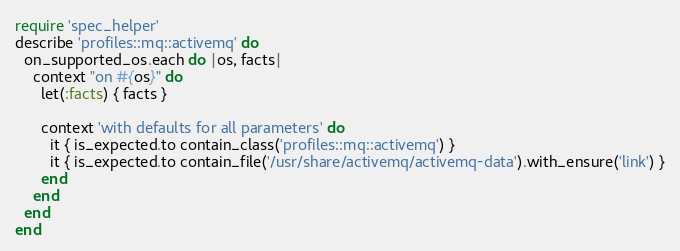<code> <loc_0><loc_0><loc_500><loc_500><_Ruby_>require 'spec_helper'
describe 'profiles::mq::activemq' do
  on_supported_os.each do |os, facts|
    context "on #{os}" do
      let(:facts) { facts }

      context 'with defaults for all parameters' do
        it { is_expected.to contain_class('profiles::mq::activemq') }
        it { is_expected.to contain_file('/usr/share/activemq/activemq-data').with_ensure('link') }
      end
    end
  end
end
</code> 